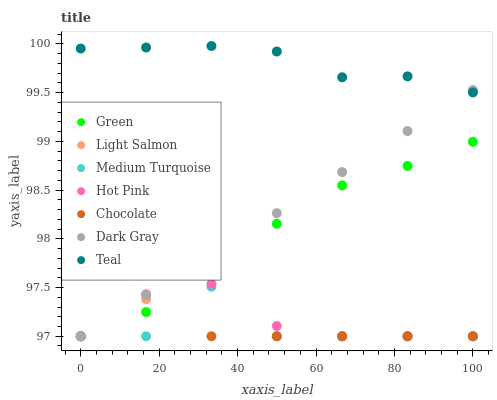Does Medium Turquoise have the minimum area under the curve?
Answer yes or no. Yes. Does Teal have the maximum area under the curve?
Answer yes or no. Yes. Does Hot Pink have the minimum area under the curve?
Answer yes or no. No. Does Hot Pink have the maximum area under the curve?
Answer yes or no. No. Is Dark Gray the smoothest?
Answer yes or no. Yes. Is Medium Turquoise the roughest?
Answer yes or no. Yes. Is Teal the smoothest?
Answer yes or no. No. Is Teal the roughest?
Answer yes or no. No. Does Light Salmon have the lowest value?
Answer yes or no. Yes. Does Teal have the lowest value?
Answer yes or no. No. Does Teal have the highest value?
Answer yes or no. Yes. Does Hot Pink have the highest value?
Answer yes or no. No. Is Green less than Teal?
Answer yes or no. Yes. Is Teal greater than Hot Pink?
Answer yes or no. Yes. Does Medium Turquoise intersect Dark Gray?
Answer yes or no. Yes. Is Medium Turquoise less than Dark Gray?
Answer yes or no. No. Is Medium Turquoise greater than Dark Gray?
Answer yes or no. No. Does Green intersect Teal?
Answer yes or no. No. 